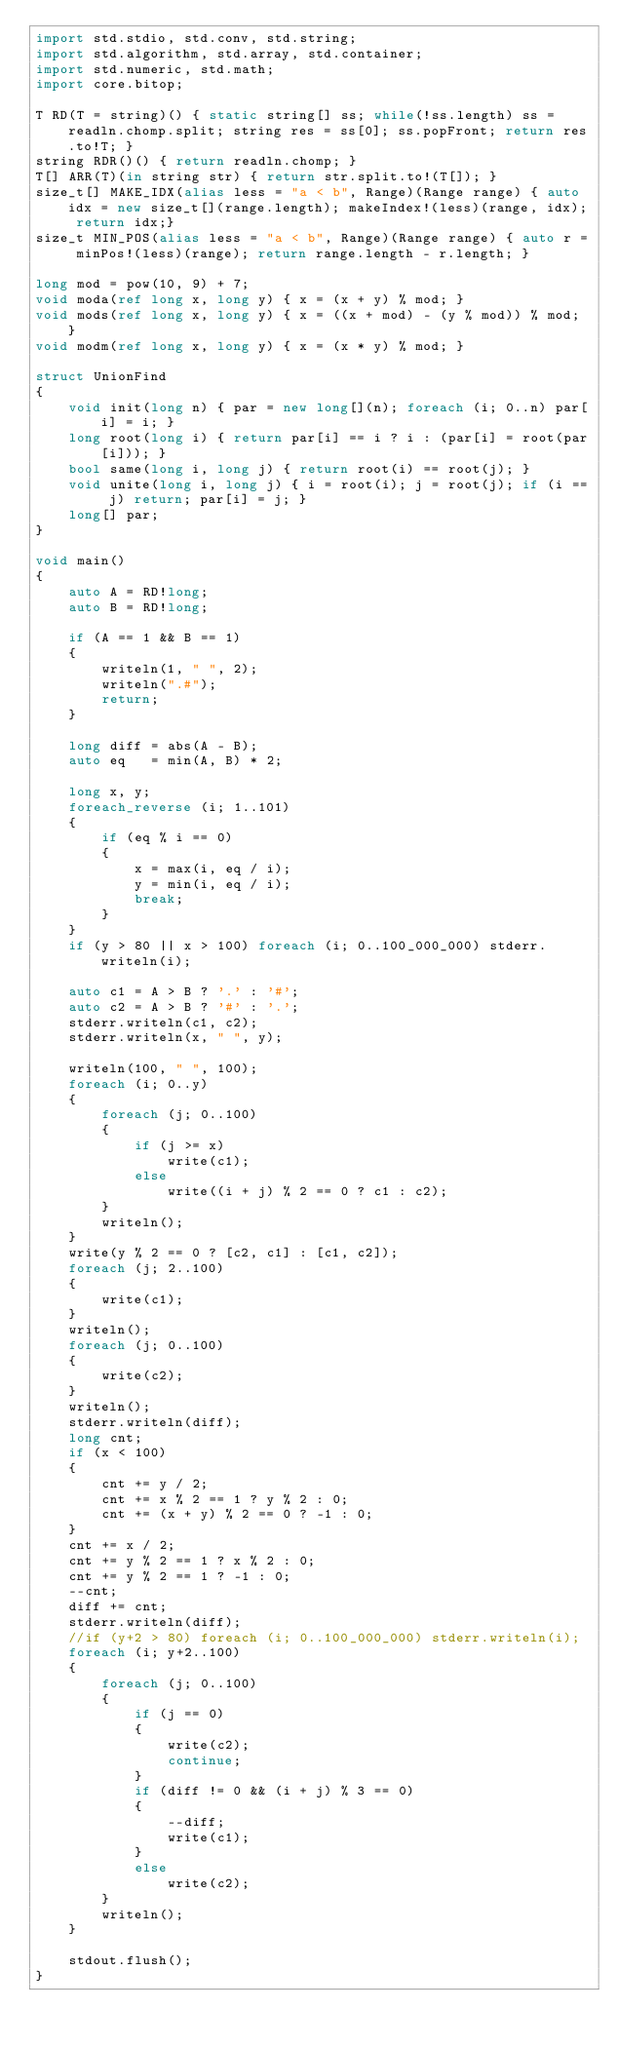<code> <loc_0><loc_0><loc_500><loc_500><_D_>import std.stdio, std.conv, std.string;
import std.algorithm, std.array, std.container;
import std.numeric, std.math;
import core.bitop;

T RD(T = string)() { static string[] ss; while(!ss.length) ss = readln.chomp.split; string res = ss[0]; ss.popFront; return res.to!T; }
string RDR()() { return readln.chomp; }
T[] ARR(T)(in string str) { return str.split.to!(T[]); }
size_t[] MAKE_IDX(alias less = "a < b", Range)(Range range) { auto idx = new size_t[](range.length); makeIndex!(less)(range, idx); return idx;}
size_t MIN_POS(alias less = "a < b", Range)(Range range) { auto r = minPos!(less)(range); return range.length - r.length; }

long mod = pow(10, 9) + 7;
void moda(ref long x, long y) { x = (x + y) % mod; }
void mods(ref long x, long y) { x = ((x + mod) - (y % mod)) % mod; }
void modm(ref long x, long y) { x = (x * y) % mod; }

struct UnionFind
{
	void init(long n) { par = new long[](n); foreach (i; 0..n) par[i] = i; }
	long root(long i) { return par[i] == i ? i : (par[i] = root(par[i])); }
	bool same(long i, long j) { return root(i) == root(j); }
	void unite(long i, long j) { i = root(i); j = root(j); if (i == j) return; par[i] = j; }
	long[] par;
}

void main()
{
	auto A = RD!long;
	auto B = RD!long;

	if (A == 1 && B == 1)
	{
		writeln(1, " ", 2);
		writeln(".#");
		return;
	}

	long diff = abs(A - B);
	auto eq   = min(A, B) * 2; 

	long x, y;
	foreach_reverse (i; 1..101)
	{
		if (eq % i == 0)
		{
			x = max(i, eq / i);
			y = min(i, eq / i);
			break;
		}
	}
	if (y > 80 || x > 100) foreach (i; 0..100_000_000) stderr.writeln(i);

	auto c1 = A > B ? '.' : '#';
	auto c2 = A > B ? '#' : '.';
	stderr.writeln(c1, c2);
	stderr.writeln(x, " ", y);

	writeln(100, " ", 100);
	foreach (i; 0..y)
	{
		foreach (j; 0..100)
		{
			if (j >= x)
				write(c1);
			else
				write((i + j) % 2 == 0 ? c1 : c2);
		}
		writeln();
	}
	write(y % 2 == 0 ? [c2, c1] : [c1, c2]);
	foreach (j; 2..100)
	{
		write(c1);
	}
	writeln();
	foreach (j; 0..100)
	{
		write(c2);
	}
	writeln();
	stderr.writeln(diff);
	long cnt;
	if (x < 100)
	{
		cnt += y / 2;
		cnt += x % 2 == 1 ? y % 2 : 0;
		cnt += (x + y) % 2 == 0 ? -1 : 0;
	}
	cnt += x / 2;
	cnt += y % 2 == 1 ? x % 2 : 0;
	cnt += y % 2 == 1 ? -1 : 0;
	--cnt;
	diff += cnt;
	stderr.writeln(diff);
	//if (y+2 > 80) foreach (i; 0..100_000_000) stderr.writeln(i);
	foreach (i; y+2..100)
	{
		foreach (j; 0..100)
		{
			if (j == 0)
			{
				write(c2);
				continue;
			}
			if (diff != 0 && (i + j) % 3 == 0)
			{
				--diff;
				write(c1);
			}
			else
				write(c2);
		}
		writeln();
	}

	stdout.flush();
}</code> 